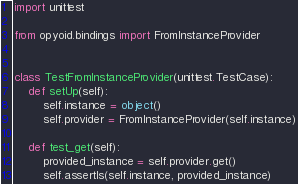Convert code to text. <code><loc_0><loc_0><loc_500><loc_500><_Python_>import unittest

from opyoid.bindings import FromInstanceProvider


class TestFromInstanceProvider(unittest.TestCase):
    def setUp(self):
        self.instance = object()
        self.provider = FromInstanceProvider(self.instance)

    def test_get(self):
        provided_instance = self.provider.get()
        self.assertIs(self.instance, provided_instance)
</code> 